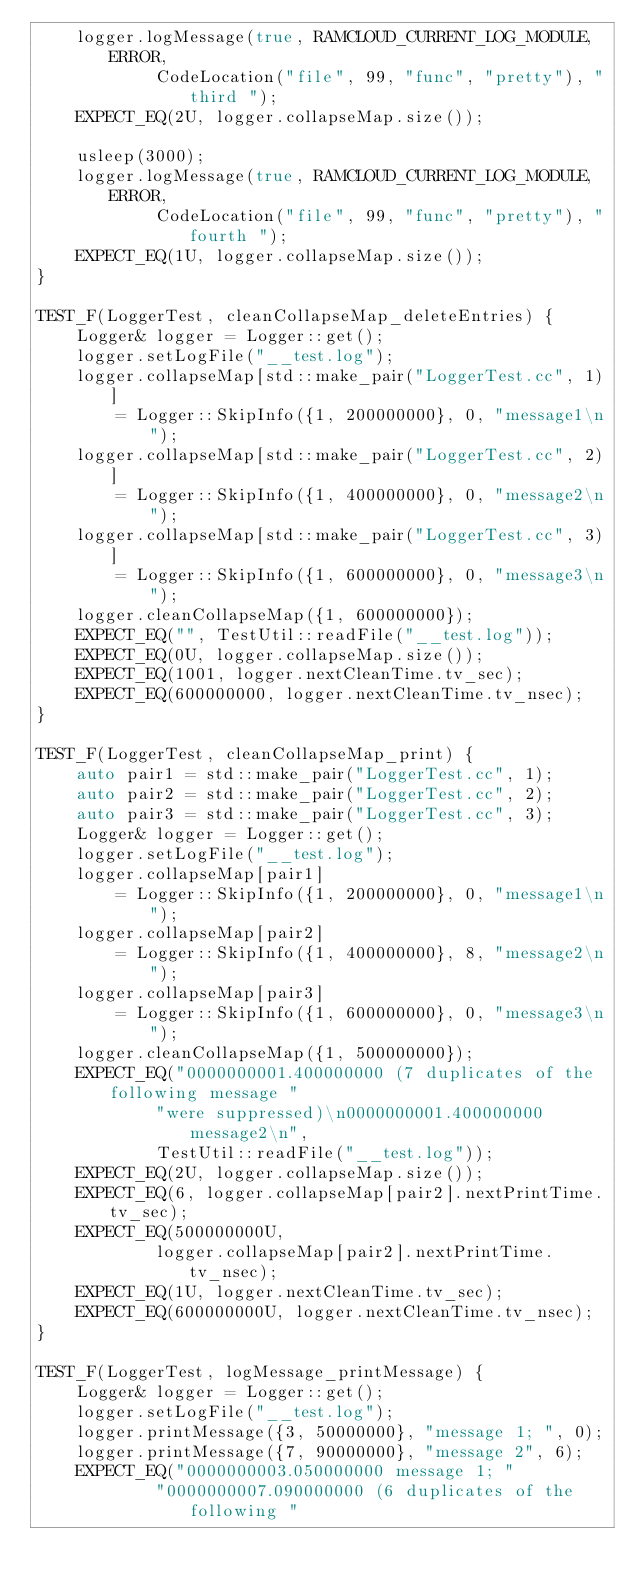<code> <loc_0><loc_0><loc_500><loc_500><_C++_>    logger.logMessage(true, RAMCLOUD_CURRENT_LOG_MODULE, ERROR,
            CodeLocation("file", 99, "func", "pretty"), "third ");
    EXPECT_EQ(2U, logger.collapseMap.size());

    usleep(3000);
    logger.logMessage(true, RAMCLOUD_CURRENT_LOG_MODULE, ERROR,
            CodeLocation("file", 99, "func", "pretty"), "fourth ");
    EXPECT_EQ(1U, logger.collapseMap.size());
}

TEST_F(LoggerTest, cleanCollapseMap_deleteEntries) {
    Logger& logger = Logger::get();
    logger.setLogFile("__test.log");
    logger.collapseMap[std::make_pair("LoggerTest.cc", 1)]
        = Logger::SkipInfo({1, 200000000}, 0, "message1\n");
    logger.collapseMap[std::make_pair("LoggerTest.cc", 2)]
        = Logger::SkipInfo({1, 400000000}, 0, "message2\n");
    logger.collapseMap[std::make_pair("LoggerTest.cc", 3)]
        = Logger::SkipInfo({1, 600000000}, 0, "message3\n");
    logger.cleanCollapseMap({1, 600000000});
    EXPECT_EQ("", TestUtil::readFile("__test.log"));
    EXPECT_EQ(0U, logger.collapseMap.size());
    EXPECT_EQ(1001, logger.nextCleanTime.tv_sec);
    EXPECT_EQ(600000000, logger.nextCleanTime.tv_nsec);
}

TEST_F(LoggerTest, cleanCollapseMap_print) {
    auto pair1 = std::make_pair("LoggerTest.cc", 1);
    auto pair2 = std::make_pair("LoggerTest.cc", 2);
    auto pair3 = std::make_pair("LoggerTest.cc", 3);
    Logger& logger = Logger::get();
    logger.setLogFile("__test.log");
    logger.collapseMap[pair1]
        = Logger::SkipInfo({1, 200000000}, 0, "message1\n");
    logger.collapseMap[pair2]
        = Logger::SkipInfo({1, 400000000}, 8, "message2\n");
    logger.collapseMap[pair3]
        = Logger::SkipInfo({1, 600000000}, 0, "message3\n");
    logger.cleanCollapseMap({1, 500000000});
    EXPECT_EQ("0000000001.400000000 (7 duplicates of the following message "
            "were suppressed)\n0000000001.400000000 message2\n",
            TestUtil::readFile("__test.log"));
    EXPECT_EQ(2U, logger.collapseMap.size());
    EXPECT_EQ(6, logger.collapseMap[pair2].nextPrintTime.tv_sec);
    EXPECT_EQ(500000000U,
            logger.collapseMap[pair2].nextPrintTime.tv_nsec);
    EXPECT_EQ(1U, logger.nextCleanTime.tv_sec);
    EXPECT_EQ(600000000U, logger.nextCleanTime.tv_nsec);
}

TEST_F(LoggerTest, logMessage_printMessage) {
    Logger& logger = Logger::get();
    logger.setLogFile("__test.log");
    logger.printMessage({3, 50000000}, "message 1; ", 0);
    logger.printMessage({7, 90000000}, "message 2", 6);
    EXPECT_EQ("0000000003.050000000 message 1; "
            "0000000007.090000000 (6 duplicates of the following "</code> 